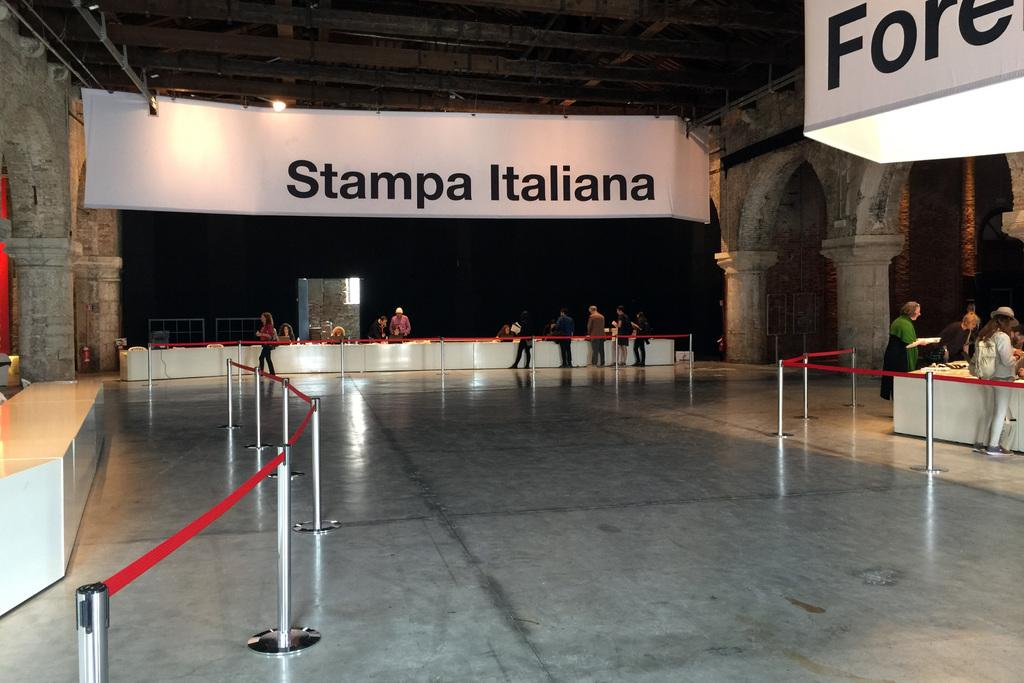How many people are in the image? There is a group of people in the image, but the exact number cannot be determined from the provided facts. What can be seen separating the people in the image? There are rope barriers in the image. What type of objects can be seen in the image? There are boards, lights, pillars, and tables in the image. What other objects can be seen in the image besides the ones mentioned? There are some other objects in the image, but their specific nature cannot be determined from the provided facts. What type of knee injury can be seen in the image? There is no mention of a knee injury or any medical condition in the image. 